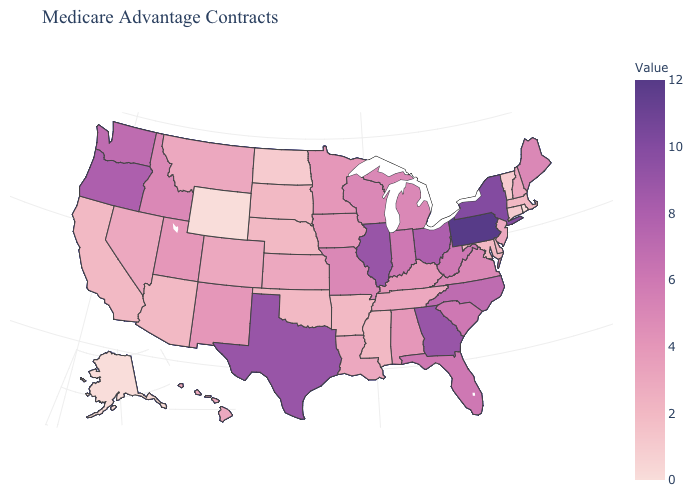Which states have the lowest value in the West?
Be succinct. Alaska, Wyoming. Is the legend a continuous bar?
Concise answer only. Yes. Does North Dakota have the lowest value in the MidWest?
Concise answer only. Yes. Does Colorado have a lower value than Washington?
Be succinct. Yes. Among the states that border Massachusetts , which have the lowest value?
Answer briefly. Rhode Island. Among the states that border Indiana , which have the lowest value?
Concise answer only. Kentucky. Is the legend a continuous bar?
Quick response, please. Yes. 